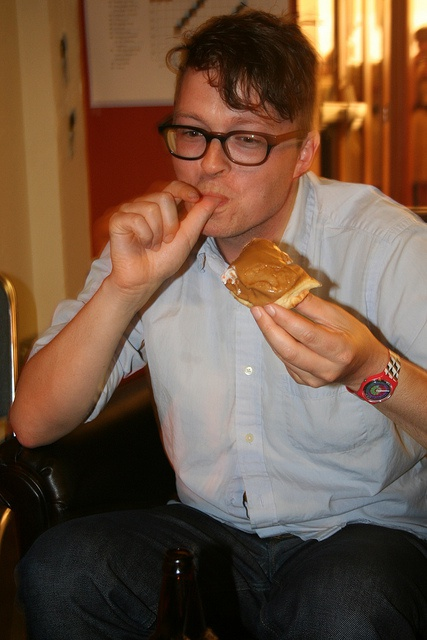Describe the objects in this image and their specific colors. I can see people in maroon, darkgray, black, salmon, and brown tones and donut in maroon, red, tan, and orange tones in this image. 